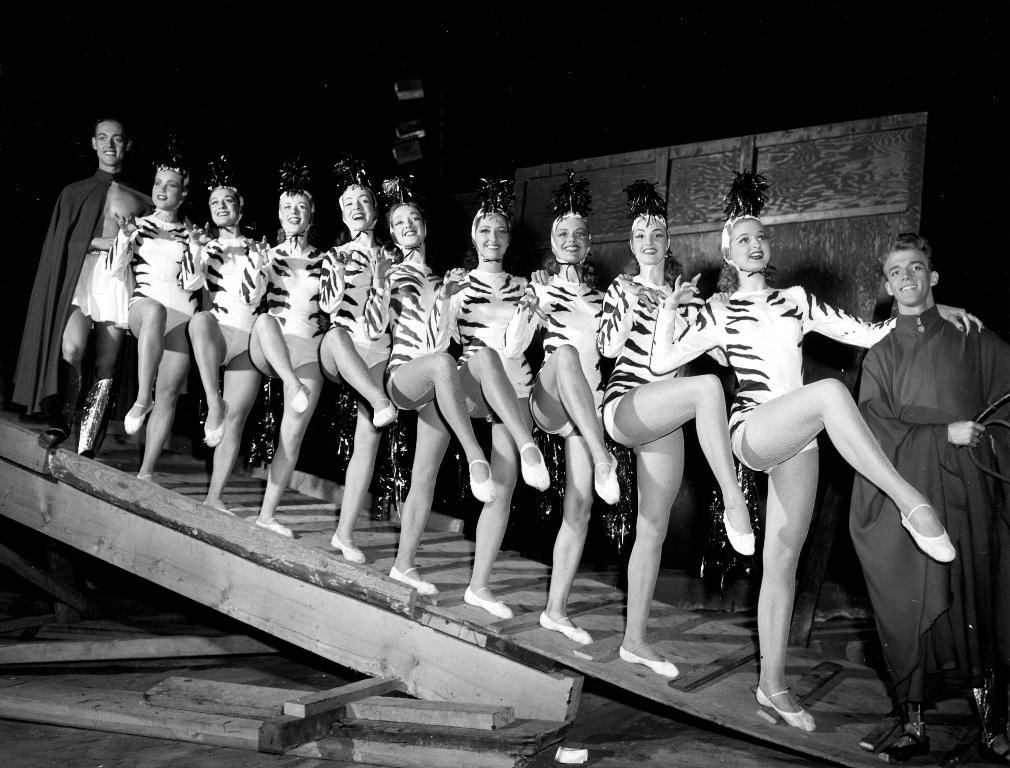What is the main subject of the image? The main subject of the image is a group of people. What are the people in the image doing? The people are standing. What are the people wearing in the image? The people are wearing dresses. What type of surface is visible in the image? The wooden surface is visible in the image. What is the color scheme of the image? The image is black and white. Can you see any rabbits in the image? There are no rabbits present in the image. What type of observation can be made about the trains in the image? There are no trains present in the image. 